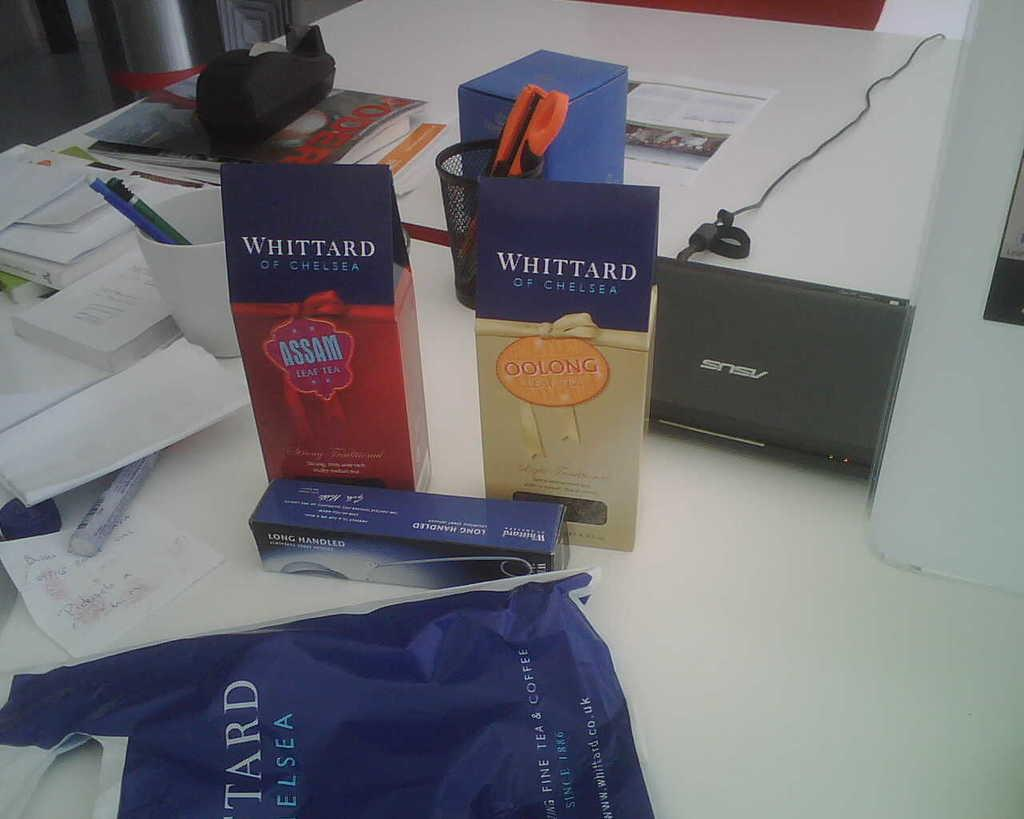<image>
Render a clear and concise summary of the photo. Two boxes of Whittard tea in different flavors are sitting on a table. 